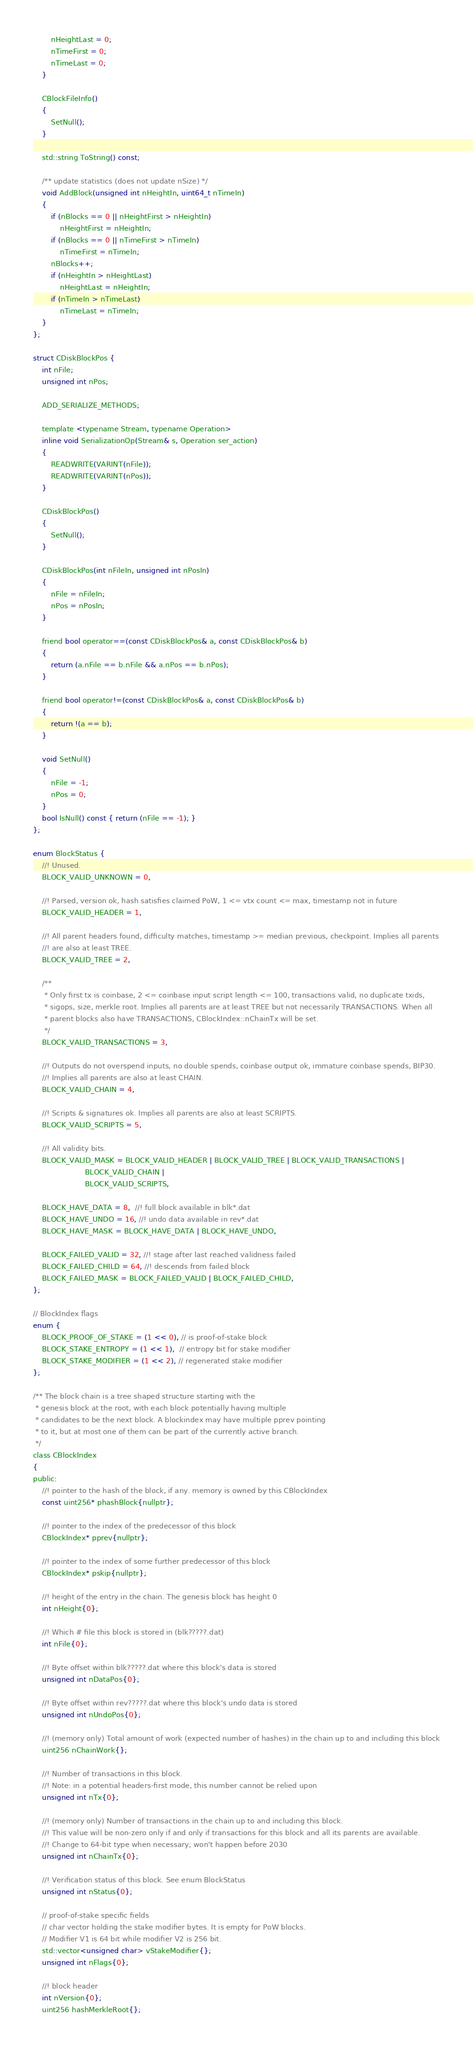Convert code to text. <code><loc_0><loc_0><loc_500><loc_500><_C_>        nHeightLast = 0;
        nTimeFirst = 0;
        nTimeLast = 0;
    }

    CBlockFileInfo()
    {
        SetNull();
    }

    std::string ToString() const;

    /** update statistics (does not update nSize) */
    void AddBlock(unsigned int nHeightIn, uint64_t nTimeIn)
    {
        if (nBlocks == 0 || nHeightFirst > nHeightIn)
            nHeightFirst = nHeightIn;
        if (nBlocks == 0 || nTimeFirst > nTimeIn)
            nTimeFirst = nTimeIn;
        nBlocks++;
        if (nHeightIn > nHeightLast)
            nHeightLast = nHeightIn;
        if (nTimeIn > nTimeLast)
            nTimeLast = nTimeIn;
    }
};

struct CDiskBlockPos {
    int nFile;
    unsigned int nPos;

    ADD_SERIALIZE_METHODS;

    template <typename Stream, typename Operation>
    inline void SerializationOp(Stream& s, Operation ser_action)
    {
        READWRITE(VARINT(nFile));
        READWRITE(VARINT(nPos));
    }

    CDiskBlockPos()
    {
        SetNull();
    }

    CDiskBlockPos(int nFileIn, unsigned int nPosIn)
    {
        nFile = nFileIn;
        nPos = nPosIn;
    }

    friend bool operator==(const CDiskBlockPos& a, const CDiskBlockPos& b)
    {
        return (a.nFile == b.nFile && a.nPos == b.nPos);
    }

    friend bool operator!=(const CDiskBlockPos& a, const CDiskBlockPos& b)
    {
        return !(a == b);
    }

    void SetNull()
    {
        nFile = -1;
        nPos = 0;
    }
    bool IsNull() const { return (nFile == -1); }
};

enum BlockStatus {
    //! Unused.
    BLOCK_VALID_UNKNOWN = 0,

    //! Parsed, version ok, hash satisfies claimed PoW, 1 <= vtx count <= max, timestamp not in future
    BLOCK_VALID_HEADER = 1,

    //! All parent headers found, difficulty matches, timestamp >= median previous, checkpoint. Implies all parents
    //! are also at least TREE.
    BLOCK_VALID_TREE = 2,

    /**
     * Only first tx is coinbase, 2 <= coinbase input script length <= 100, transactions valid, no duplicate txids,
     * sigops, size, merkle root. Implies all parents are at least TREE but not necessarily TRANSACTIONS. When all
     * parent blocks also have TRANSACTIONS, CBlockIndex::nChainTx will be set.
     */
    BLOCK_VALID_TRANSACTIONS = 3,

    //! Outputs do not overspend inputs, no double spends, coinbase output ok, immature coinbase spends, BIP30.
    //! Implies all parents are also at least CHAIN.
    BLOCK_VALID_CHAIN = 4,

    //! Scripts & signatures ok. Implies all parents are also at least SCRIPTS.
    BLOCK_VALID_SCRIPTS = 5,

    //! All validity bits.
    BLOCK_VALID_MASK = BLOCK_VALID_HEADER | BLOCK_VALID_TREE | BLOCK_VALID_TRANSACTIONS |
                       BLOCK_VALID_CHAIN |
                       BLOCK_VALID_SCRIPTS,

    BLOCK_HAVE_DATA = 8,  //! full block available in blk*.dat
    BLOCK_HAVE_UNDO = 16, //! undo data available in rev*.dat
    BLOCK_HAVE_MASK = BLOCK_HAVE_DATA | BLOCK_HAVE_UNDO,

    BLOCK_FAILED_VALID = 32, //! stage after last reached validness failed
    BLOCK_FAILED_CHILD = 64, //! descends from failed block
    BLOCK_FAILED_MASK = BLOCK_FAILED_VALID | BLOCK_FAILED_CHILD,
};

// BlockIndex flags
enum {
    BLOCK_PROOF_OF_STAKE = (1 << 0), // is proof-of-stake block
    BLOCK_STAKE_ENTROPY = (1 << 1),  // entropy bit for stake modifier
    BLOCK_STAKE_MODIFIER = (1 << 2), // regenerated stake modifier
};

/** The block chain is a tree shaped structure starting with the
 * genesis block at the root, with each block potentially having multiple
 * candidates to be the next block. A blockindex may have multiple pprev pointing
 * to it, but at most one of them can be part of the currently active branch.
 */
class CBlockIndex
{
public:
    //! pointer to the hash of the block, if any. memory is owned by this CBlockIndex
    const uint256* phashBlock{nullptr};

    //! pointer to the index of the predecessor of this block
    CBlockIndex* pprev{nullptr};

    //! pointer to the index of some further predecessor of this block
    CBlockIndex* pskip{nullptr};

    //! height of the entry in the chain. The genesis block has height 0
    int nHeight{0};

    //! Which # file this block is stored in (blk?????.dat)
    int nFile{0};

    //! Byte offset within blk?????.dat where this block's data is stored
    unsigned int nDataPos{0};

    //! Byte offset within rev?????.dat where this block's undo data is stored
    unsigned int nUndoPos{0};

    //! (memory only) Total amount of work (expected number of hashes) in the chain up to and including this block
    uint256 nChainWork{};

    //! Number of transactions in this block.
    //! Note: in a potential headers-first mode, this number cannot be relied upon
    unsigned int nTx{0};

    //! (memory only) Number of transactions in the chain up to and including this block.
    //! This value will be non-zero only if and only if transactions for this block and all its parents are available.
    //! Change to 64-bit type when necessary; won't happen before 2030
    unsigned int nChainTx{0};

    //! Verification status of this block. See enum BlockStatus
    unsigned int nStatus{0};

    // proof-of-stake specific fields
    // char vector holding the stake modifier bytes. It is empty for PoW blocks.
    // Modifier V1 is 64 bit while modifier V2 is 256 bit.
    std::vector<unsigned char> vStakeModifier{};
    unsigned int nFlags{0};

    //! block header
    int nVersion{0};
    uint256 hashMerkleRoot{};</code> 